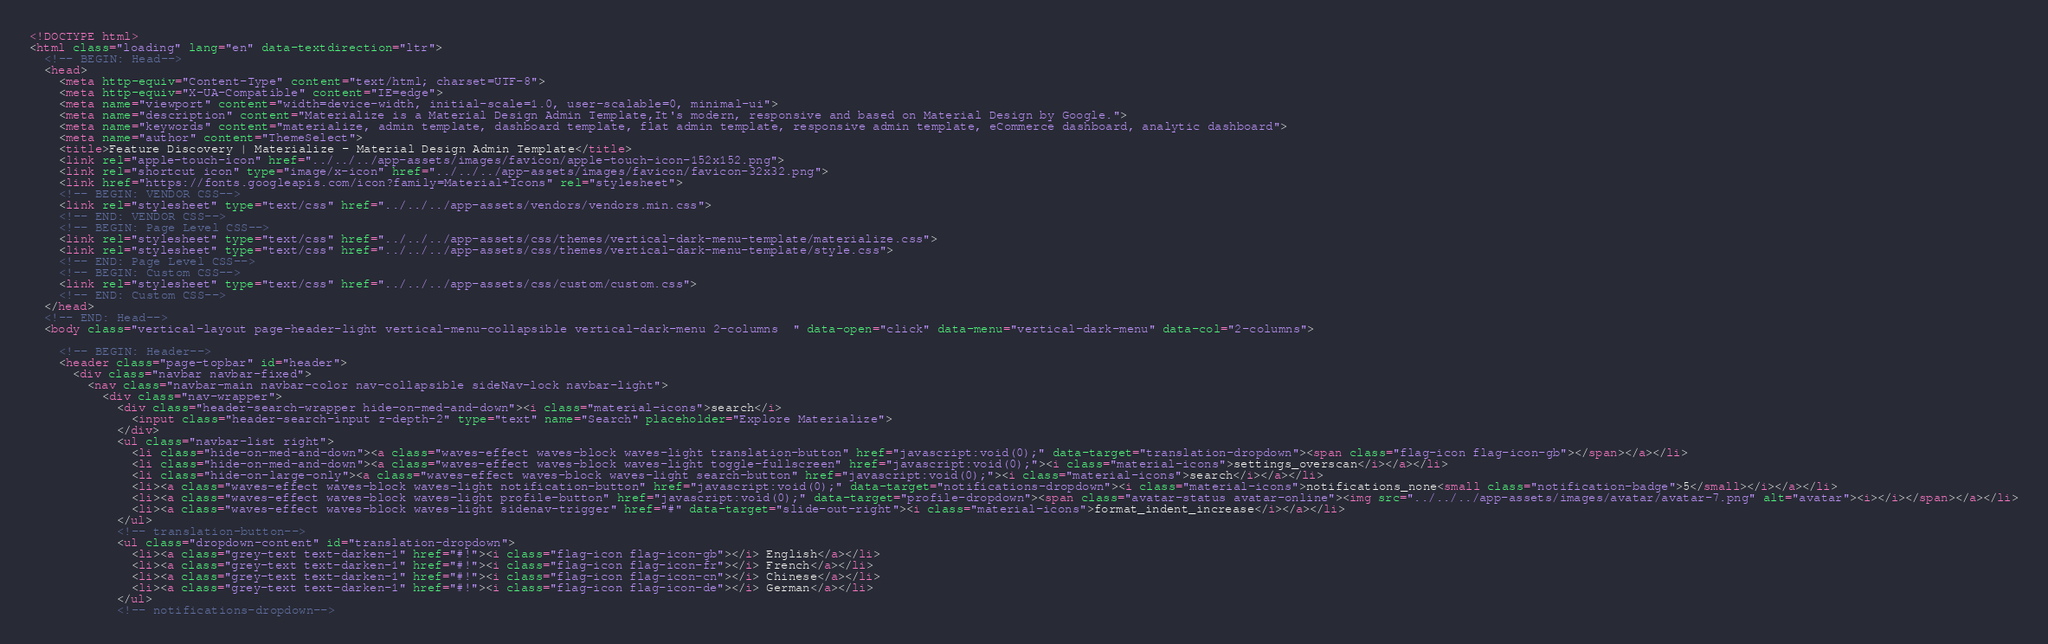Convert code to text. <code><loc_0><loc_0><loc_500><loc_500><_HTML_><!DOCTYPE html>
<html class="loading" lang="en" data-textdirection="ltr">
  <!-- BEGIN: Head-->
  <head>
    <meta http-equiv="Content-Type" content="text/html; charset=UTF-8">
    <meta http-equiv="X-UA-Compatible" content="IE=edge">
    <meta name="viewport" content="width=device-width, initial-scale=1.0, user-scalable=0, minimal-ui">
    <meta name="description" content="Materialize is a Material Design Admin Template,It's modern, responsive and based on Material Design by Google.">
    <meta name="keywords" content="materialize, admin template, dashboard template, flat admin template, responsive admin template, eCommerce dashboard, analytic dashboard">
    <meta name="author" content="ThemeSelect">
    <title>Feature Discovery | Materialize - Material Design Admin Template</title>
    <link rel="apple-touch-icon" href="../../../app-assets/images/favicon/apple-touch-icon-152x152.png">
    <link rel="shortcut icon" type="image/x-icon" href="../../../app-assets/images/favicon/favicon-32x32.png">
    <link href="https://fonts.googleapis.com/icon?family=Material+Icons" rel="stylesheet">
    <!-- BEGIN: VENDOR CSS-->
    <link rel="stylesheet" type="text/css" href="../../../app-assets/vendors/vendors.min.css">
    <!-- END: VENDOR CSS-->
    <!-- BEGIN: Page Level CSS-->
    <link rel="stylesheet" type="text/css" href="../../../app-assets/css/themes/vertical-dark-menu-template/materialize.css">
    <link rel="stylesheet" type="text/css" href="../../../app-assets/css/themes/vertical-dark-menu-template/style.css">
    <!-- END: Page Level CSS-->
    <!-- BEGIN: Custom CSS-->
    <link rel="stylesheet" type="text/css" href="../../../app-assets/css/custom/custom.css">
    <!-- END: Custom CSS-->
  </head>
  <!-- END: Head-->
  <body class="vertical-layout page-header-light vertical-menu-collapsible vertical-dark-menu 2-columns  " data-open="click" data-menu="vertical-dark-menu" data-col="2-columns">

    <!-- BEGIN: Header-->
    <header class="page-topbar" id="header">
      <div class="navbar navbar-fixed"> 
        <nav class="navbar-main navbar-color nav-collapsible sideNav-lock navbar-light">
          <div class="nav-wrapper">
            <div class="header-search-wrapper hide-on-med-and-down"><i class="material-icons">search</i>
              <input class="header-search-input z-depth-2" type="text" name="Search" placeholder="Explore Materialize">
            </div>
            <ul class="navbar-list right">
              <li class="hide-on-med-and-down"><a class="waves-effect waves-block waves-light translation-button" href="javascript:void(0);" data-target="translation-dropdown"><span class="flag-icon flag-icon-gb"></span></a></li>
              <li class="hide-on-med-and-down"><a class="waves-effect waves-block waves-light toggle-fullscreen" href="javascript:void(0);"><i class="material-icons">settings_overscan</i></a></li>
              <li class="hide-on-large-only"><a class="waves-effect waves-block waves-light search-button" href="javascript:void(0);"><i class="material-icons">search</i></a></li>
              <li><a class="waves-effect waves-block waves-light notification-button" href="javascript:void(0);" data-target="notifications-dropdown"><i class="material-icons">notifications_none<small class="notification-badge">5</small></i></a></li>
              <li><a class="waves-effect waves-block waves-light profile-button" href="javascript:void(0);" data-target="profile-dropdown"><span class="avatar-status avatar-online"><img src="../../../app-assets/images/avatar/avatar-7.png" alt="avatar"><i></i></span></a></li>
              <li><a class="waves-effect waves-block waves-light sidenav-trigger" href="#" data-target="slide-out-right"><i class="material-icons">format_indent_increase</i></a></li>
            </ul>
            <!-- translation-button-->
            <ul class="dropdown-content" id="translation-dropdown">
              <li><a class="grey-text text-darken-1" href="#!"><i class="flag-icon flag-icon-gb"></i> English</a></li>
              <li><a class="grey-text text-darken-1" href="#!"><i class="flag-icon flag-icon-fr"></i> French</a></li>
              <li><a class="grey-text text-darken-1" href="#!"><i class="flag-icon flag-icon-cn"></i> Chinese</a></li>
              <li><a class="grey-text text-darken-1" href="#!"><i class="flag-icon flag-icon-de"></i> German</a></li>
            </ul>
            <!-- notifications-dropdown--></code> 